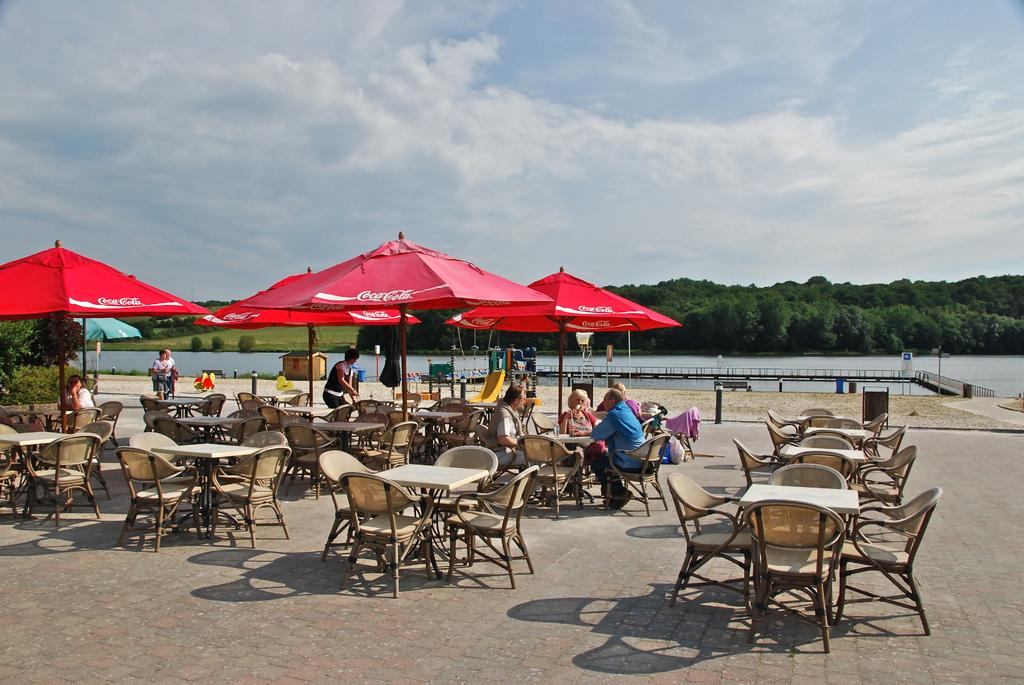How many people are in the image? There are many people in the image. Where are the people located in the image? The people are under a Coca Cola tent. What can be seen in the background of the image? There is a beautiful scenery and a lake in the background of the image. What type of furniture can be seen in the image? There is no furniture present in the image. How many stars are visible in the image? There are no stars visible in the image. 